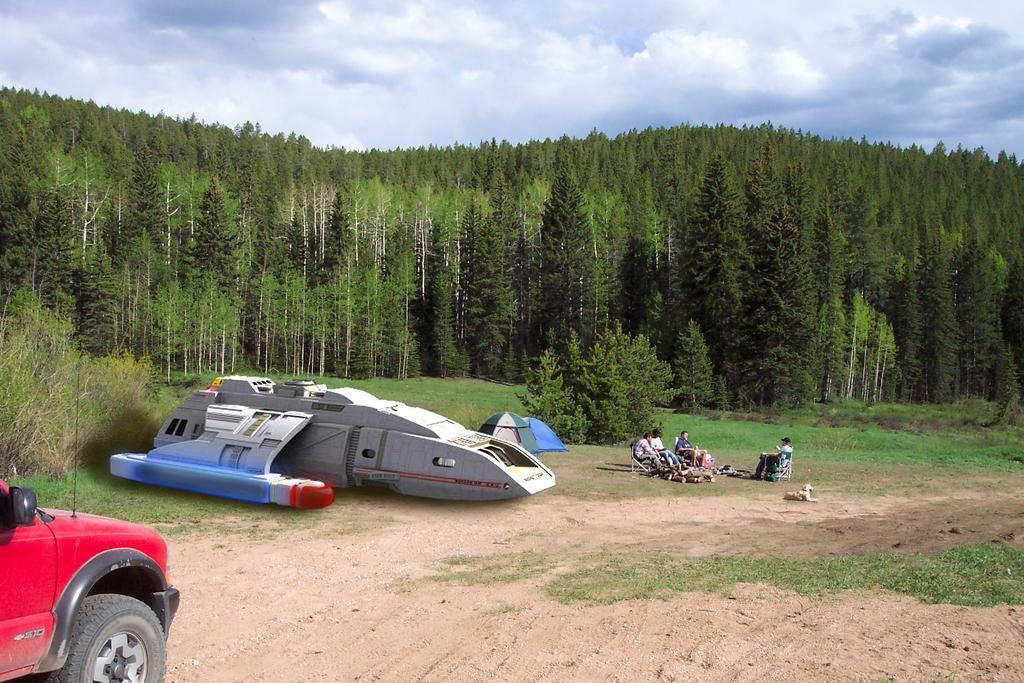Could you give a brief overview of what you see in this image? This picture is clicked outside the city. On the the left corner there is a red color car is parked on the ground. In the center there is a white color object placed on the ground and we can see the tents and group of people sitting on the chairs and there is an animal sitting on the ground and we can see there are some objects placed on the ground. In the background we can see the green grass, plants, trees and the sky. 